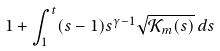Convert formula to latex. <formula><loc_0><loc_0><loc_500><loc_500>1 + \int _ { 1 } ^ { t } ( s - 1 ) s ^ { \gamma - 1 } \sqrt { \mathcal { K } _ { m } ( s ) } \, d s</formula> 